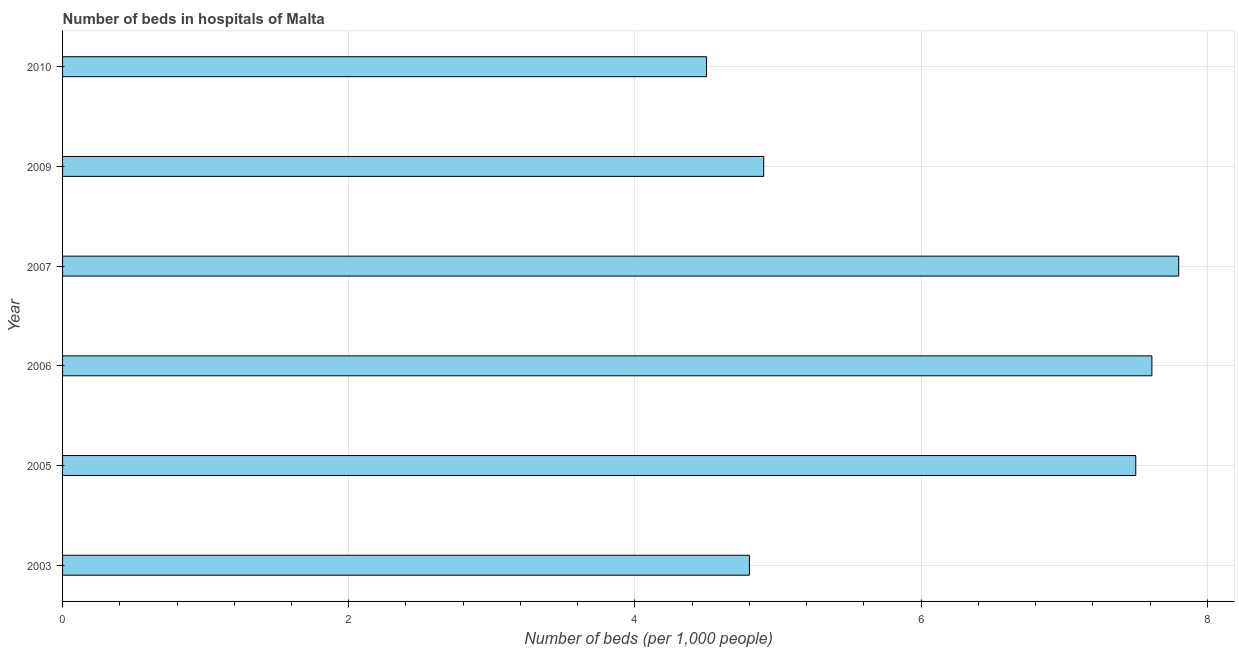Does the graph contain any zero values?
Give a very brief answer. No. What is the title of the graph?
Offer a very short reply. Number of beds in hospitals of Malta. What is the label or title of the X-axis?
Provide a succinct answer. Number of beds (per 1,0 people). What is the number of hospital beds in 2010?
Provide a short and direct response. 4.5. In which year was the number of hospital beds maximum?
Your response must be concise. 2007. What is the sum of the number of hospital beds?
Offer a terse response. 37.11. What is the difference between the number of hospital beds in 2005 and 2010?
Your answer should be compact. 3. What is the average number of hospital beds per year?
Offer a very short reply. 6.18. In how many years, is the number of hospital beds greater than 0.4 %?
Your answer should be very brief. 6. What is the ratio of the number of hospital beds in 2009 to that in 2010?
Ensure brevity in your answer.  1.09. Is the number of hospital beds in 2006 less than that in 2009?
Your answer should be compact. No. Is the difference between the number of hospital beds in 2007 and 2009 greater than the difference between any two years?
Offer a very short reply. No. What is the difference between the highest and the second highest number of hospital beds?
Offer a very short reply. 0.19. Is the sum of the number of hospital beds in 2005 and 2006 greater than the maximum number of hospital beds across all years?
Make the answer very short. Yes. What is the difference between the highest and the lowest number of hospital beds?
Keep it short and to the point. 3.3. In how many years, is the number of hospital beds greater than the average number of hospital beds taken over all years?
Provide a short and direct response. 3. How many years are there in the graph?
Keep it short and to the point. 6. What is the difference between two consecutive major ticks on the X-axis?
Offer a terse response. 2. Are the values on the major ticks of X-axis written in scientific E-notation?
Your answer should be very brief. No. What is the Number of beds (per 1,000 people) in 2003?
Provide a short and direct response. 4.8. What is the Number of beds (per 1,000 people) of 2005?
Make the answer very short. 7.5. What is the Number of beds (per 1,000 people) in 2006?
Offer a very short reply. 7.61. What is the Number of beds (per 1,000 people) of 2009?
Your answer should be very brief. 4.9. What is the Number of beds (per 1,000 people) in 2010?
Ensure brevity in your answer.  4.5. What is the difference between the Number of beds (per 1,000 people) in 2003 and 2005?
Provide a succinct answer. -2.7. What is the difference between the Number of beds (per 1,000 people) in 2003 and 2006?
Offer a terse response. -2.81. What is the difference between the Number of beds (per 1,000 people) in 2003 and 2007?
Offer a terse response. -3. What is the difference between the Number of beds (per 1,000 people) in 2005 and 2006?
Offer a very short reply. -0.11. What is the difference between the Number of beds (per 1,000 people) in 2005 and 2010?
Keep it short and to the point. 3. What is the difference between the Number of beds (per 1,000 people) in 2006 and 2007?
Give a very brief answer. -0.19. What is the difference between the Number of beds (per 1,000 people) in 2006 and 2009?
Give a very brief answer. 2.71. What is the difference between the Number of beds (per 1,000 people) in 2006 and 2010?
Give a very brief answer. 3.11. What is the difference between the Number of beds (per 1,000 people) in 2007 and 2009?
Your response must be concise. 2.9. What is the difference between the Number of beds (per 1,000 people) in 2009 and 2010?
Offer a terse response. 0.4. What is the ratio of the Number of beds (per 1,000 people) in 2003 to that in 2005?
Your answer should be very brief. 0.64. What is the ratio of the Number of beds (per 1,000 people) in 2003 to that in 2006?
Offer a terse response. 0.63. What is the ratio of the Number of beds (per 1,000 people) in 2003 to that in 2007?
Make the answer very short. 0.61. What is the ratio of the Number of beds (per 1,000 people) in 2003 to that in 2009?
Your answer should be compact. 0.98. What is the ratio of the Number of beds (per 1,000 people) in 2003 to that in 2010?
Give a very brief answer. 1.07. What is the ratio of the Number of beds (per 1,000 people) in 2005 to that in 2009?
Provide a succinct answer. 1.53. What is the ratio of the Number of beds (per 1,000 people) in 2005 to that in 2010?
Give a very brief answer. 1.67. What is the ratio of the Number of beds (per 1,000 people) in 2006 to that in 2007?
Offer a very short reply. 0.98. What is the ratio of the Number of beds (per 1,000 people) in 2006 to that in 2009?
Give a very brief answer. 1.55. What is the ratio of the Number of beds (per 1,000 people) in 2006 to that in 2010?
Make the answer very short. 1.69. What is the ratio of the Number of beds (per 1,000 people) in 2007 to that in 2009?
Your answer should be very brief. 1.59. What is the ratio of the Number of beds (per 1,000 people) in 2007 to that in 2010?
Give a very brief answer. 1.73. What is the ratio of the Number of beds (per 1,000 people) in 2009 to that in 2010?
Offer a terse response. 1.09. 